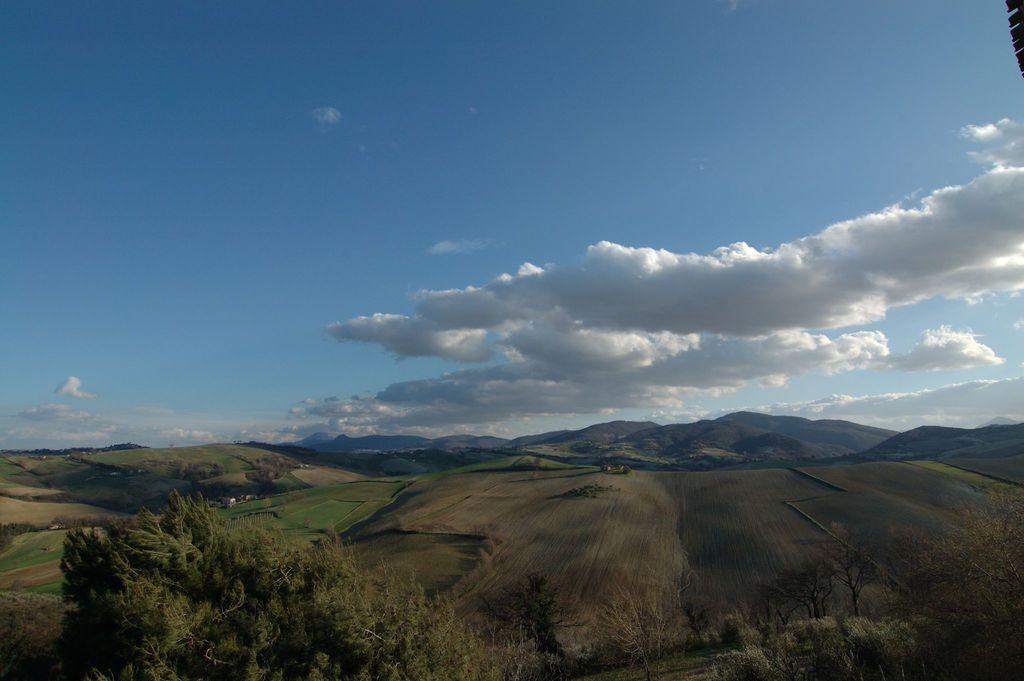Could you give a brief overview of what you see in this image? In this picture we can see many mountains. On the left we can see the farmland. At the bottom we can see the many trees. At the top we can see sky and clouds. 